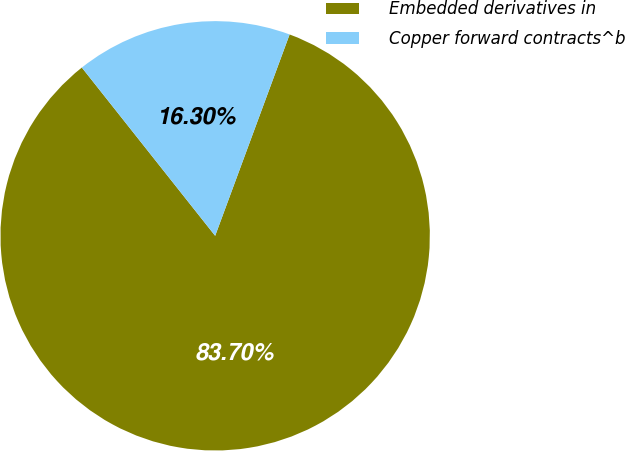Convert chart. <chart><loc_0><loc_0><loc_500><loc_500><pie_chart><fcel>Embedded derivatives in<fcel>Copper forward contracts^b<nl><fcel>83.7%<fcel>16.3%<nl></chart> 